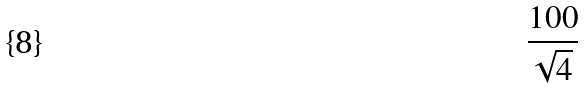Convert formula to latex. <formula><loc_0><loc_0><loc_500><loc_500>\frac { 1 0 0 } { \sqrt { 4 } }</formula> 